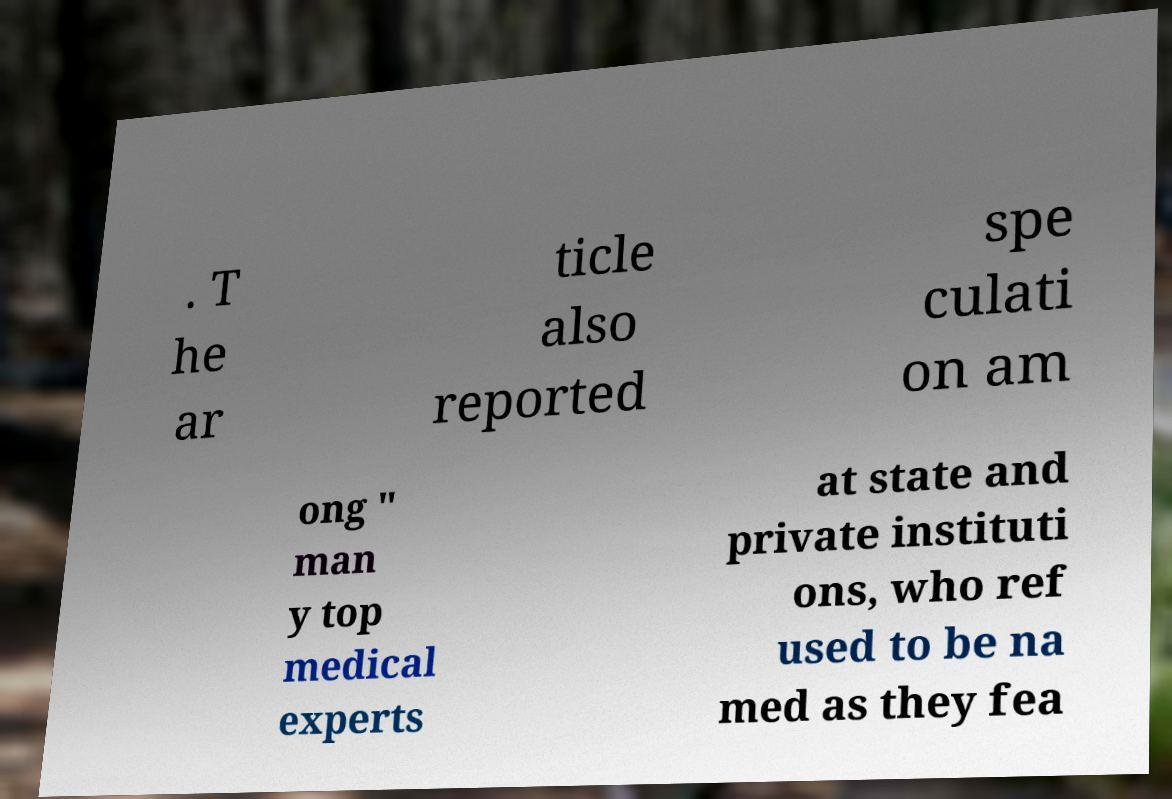For documentation purposes, I need the text within this image transcribed. Could you provide that? . T he ar ticle also reported spe culati on am ong " man y top medical experts at state and private instituti ons, who ref used to be na med as they fea 